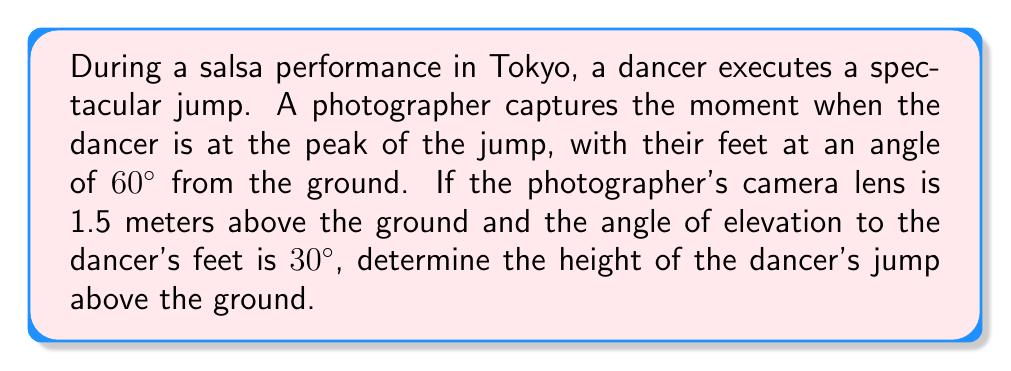Give your solution to this math problem. Let's approach this step-by-step:

1) First, let's visualize the scenario:

   [asy]
   import geometry;
   
   size(200);
   
   pair A = (0,0), B = (3,0), C = (3,5.2), D = (3,1.5);
   
   draw(A--B--C--A);
   draw(B--D,dashed);
   
   label("Ground", (1.5,0), S);
   label("Camera", D, E);
   label("Dancer", C, E);
   label("1.5m", (3.2,0.75), E);
   label("h", (3.2,3.35), E);
   label("30°", (0.3,0.3), NW);
   label("60°", (2.7,4.9), NW);
   
   draw(arc(B,0.5,0,30),Arrow);
   draw(arc(C,0.5,180,240),Arrow);
   [/asy]

2) Let's define our variables:
   - Let $h$ be the height of the dancer's jump
   - The camera is 1.5m above the ground
   - The angle of elevation to the dancer's feet is $30°$

3) We can use the tangent function to find the horizontal distance from the camera to the dancer:

   $$\tan(30°) = \frac{h - 1.5}{x}$$

   where $x$ is the horizontal distance.

4) We know that $\tan(30°) = \frac{1}{\sqrt{3}}$, so:

   $$\frac{1}{\sqrt{3}} = \frac{h - 1.5}{x}$$

5) Now, we can use the fact that the dancer's feet are at a $60°$ angle from the ground:

   $$\tan(60°) = \frac{h}{x}$$

6) We know that $\tan(60°) = \sqrt{3}$, so:

   $$\sqrt{3} = \frac{h}{x}$$

7) From step 4, we can express $x$ in terms of $h$:

   $$x = (h - 1.5)\sqrt{3}$$

8) Substituting this into the equation from step 6:

   $$\sqrt{3} = \frac{h}{(h - 1.5)\sqrt{3}}$$

9) Simplifying:

   $$3 = \frac{h}{h - 1.5}$$

10) Cross-multiplying:

    $$3h - 4.5 = h$$

11) Solving for $h$:

    $$2h = 4.5$$
    $$h = 2.25$$

Therefore, the height of the dancer's jump is 2.25 meters above the ground.
Answer: 2.25 meters 